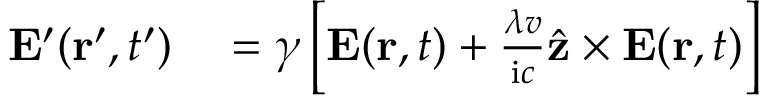Convert formula to latex. <formula><loc_0><loc_0><loc_500><loc_500>\begin{array} { r l } { E ^ { \prime } ( r ^ { \prime } , t ^ { \prime } ) } & = \gamma \left [ E ( r , t ) + \frac { \lambda v } { i c } \hat { z } \times E ( r , t ) \right ] } \end{array}</formula> 